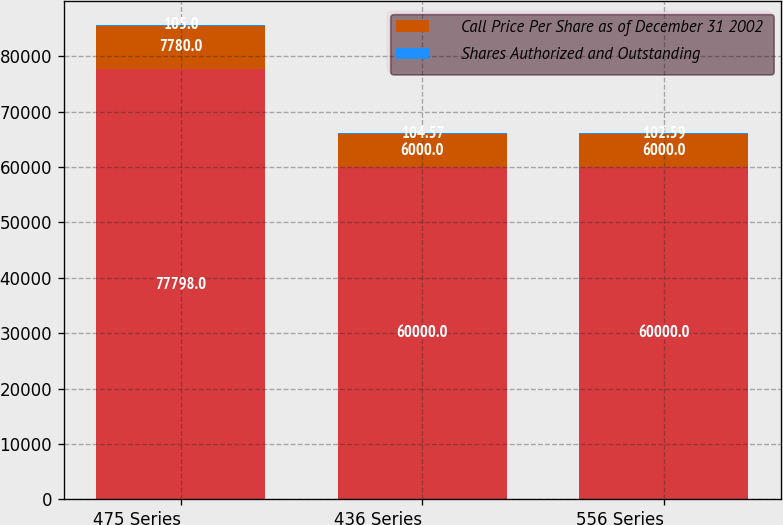Convert chart to OTSL. <chart><loc_0><loc_0><loc_500><loc_500><stacked_bar_chart><ecel><fcel>475 Series<fcel>436 Series<fcel>556 Series<nl><fcel>nan<fcel>77798<fcel>60000<fcel>60000<nl><fcel>Call Price Per Share as of December 31 2002<fcel>7780<fcel>6000<fcel>6000<nl><fcel>Shares Authorized and Outstanding<fcel>105<fcel>104.57<fcel>102.59<nl></chart> 